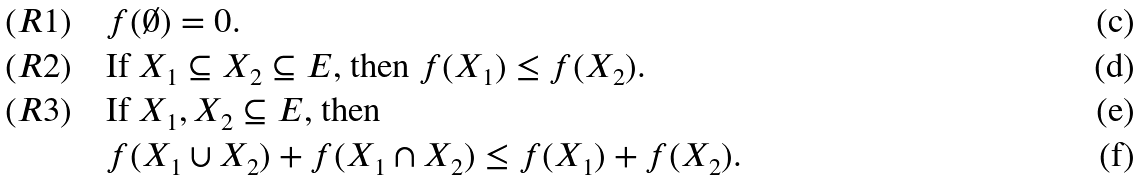<formula> <loc_0><loc_0><loc_500><loc_500>( R 1 ) \quad & \text {$f(\emptyset) =0$} . \\ ( R 2 ) \quad & \text {If $X_{1} \subseteq X_{2} \subseteq E$, then $ f(X_{1}) \leq f(X_{2})$} . \\ ( R 3 ) \quad & \text {If $X_{1} , X_{2} \subseteq E$, then } \\ & f ( X _ { 1 } \cup X _ { 2 } ) + f ( X _ { 1 } \cap X _ { 2 } ) \leq f ( X _ { 1 } ) + f ( X _ { 2 } ) .</formula> 